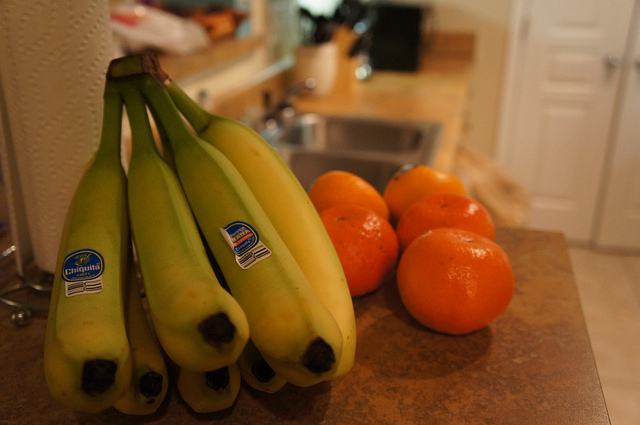How many bananas are there? 7 